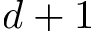<formula> <loc_0><loc_0><loc_500><loc_500>d + 1</formula> 